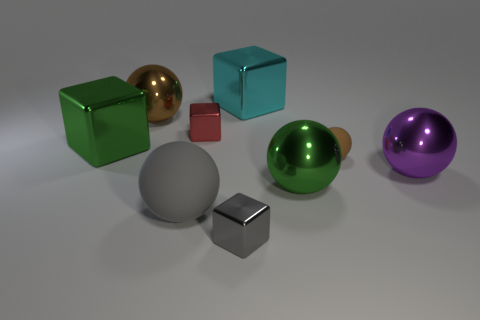There is a large shiny thing that is the same color as the small ball; what is its shape?
Your response must be concise. Sphere. What number of small metal cubes have the same color as the big rubber thing?
Your answer should be compact. 1. There is a gray object that is the same size as the red metallic thing; what shape is it?
Make the answer very short. Cube. Are there fewer tiny objects than balls?
Offer a very short reply. Yes. Is there a green ball behind the tiny metal object in front of the big green cube?
Provide a succinct answer. Yes. Are there any big metallic cubes that are in front of the big brown ball that is behind the large object that is on the right side of the small brown sphere?
Your answer should be very brief. Yes. Is the shape of the matte object on the left side of the tiny rubber object the same as the large green metal thing on the left side of the brown metallic thing?
Offer a very short reply. No. There is a tiny thing that is the same material as the gray block; what is its color?
Offer a very short reply. Red. Are there fewer big spheres in front of the gray metal cube than shiny spheres?
Your answer should be very brief. Yes. How big is the green shiny object to the right of the object behind the big metal sphere to the left of the gray metallic block?
Offer a terse response. Large. 